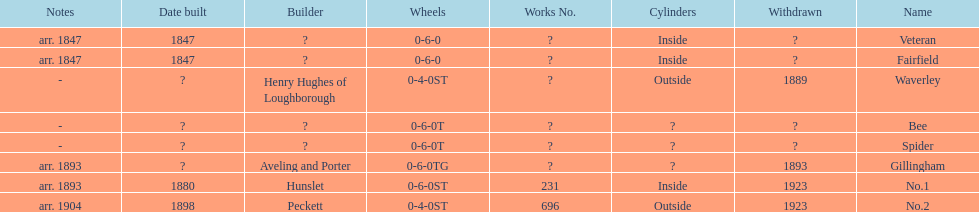Was no.1 or veteran built in 1847? Veteran. 